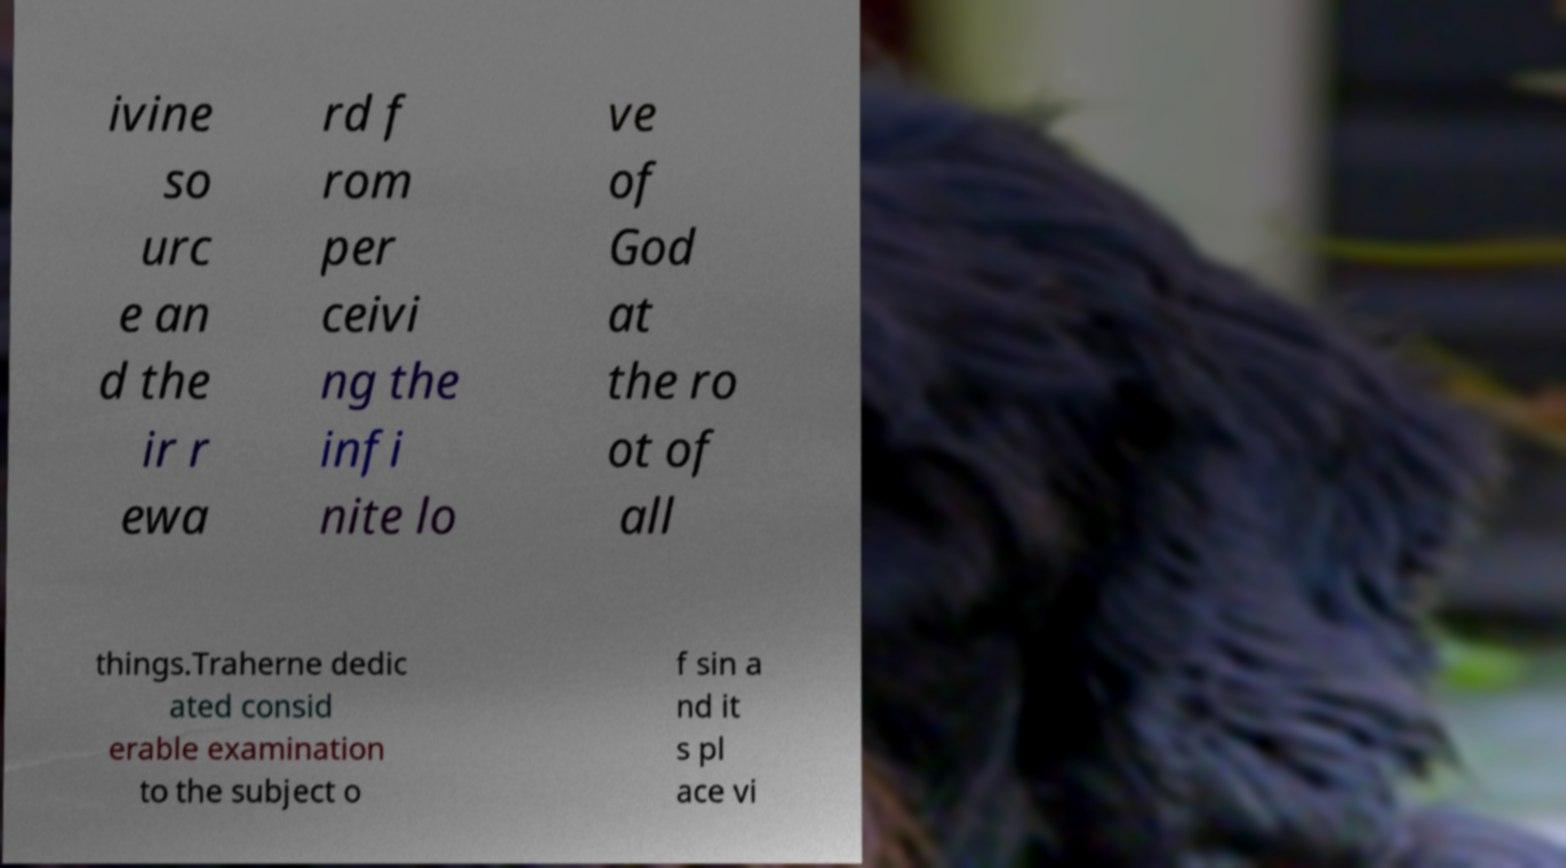Please identify and transcribe the text found in this image. ivine so urc e an d the ir r ewa rd f rom per ceivi ng the infi nite lo ve of God at the ro ot of all things.Traherne dedic ated consid erable examination to the subject o f sin a nd it s pl ace vi 